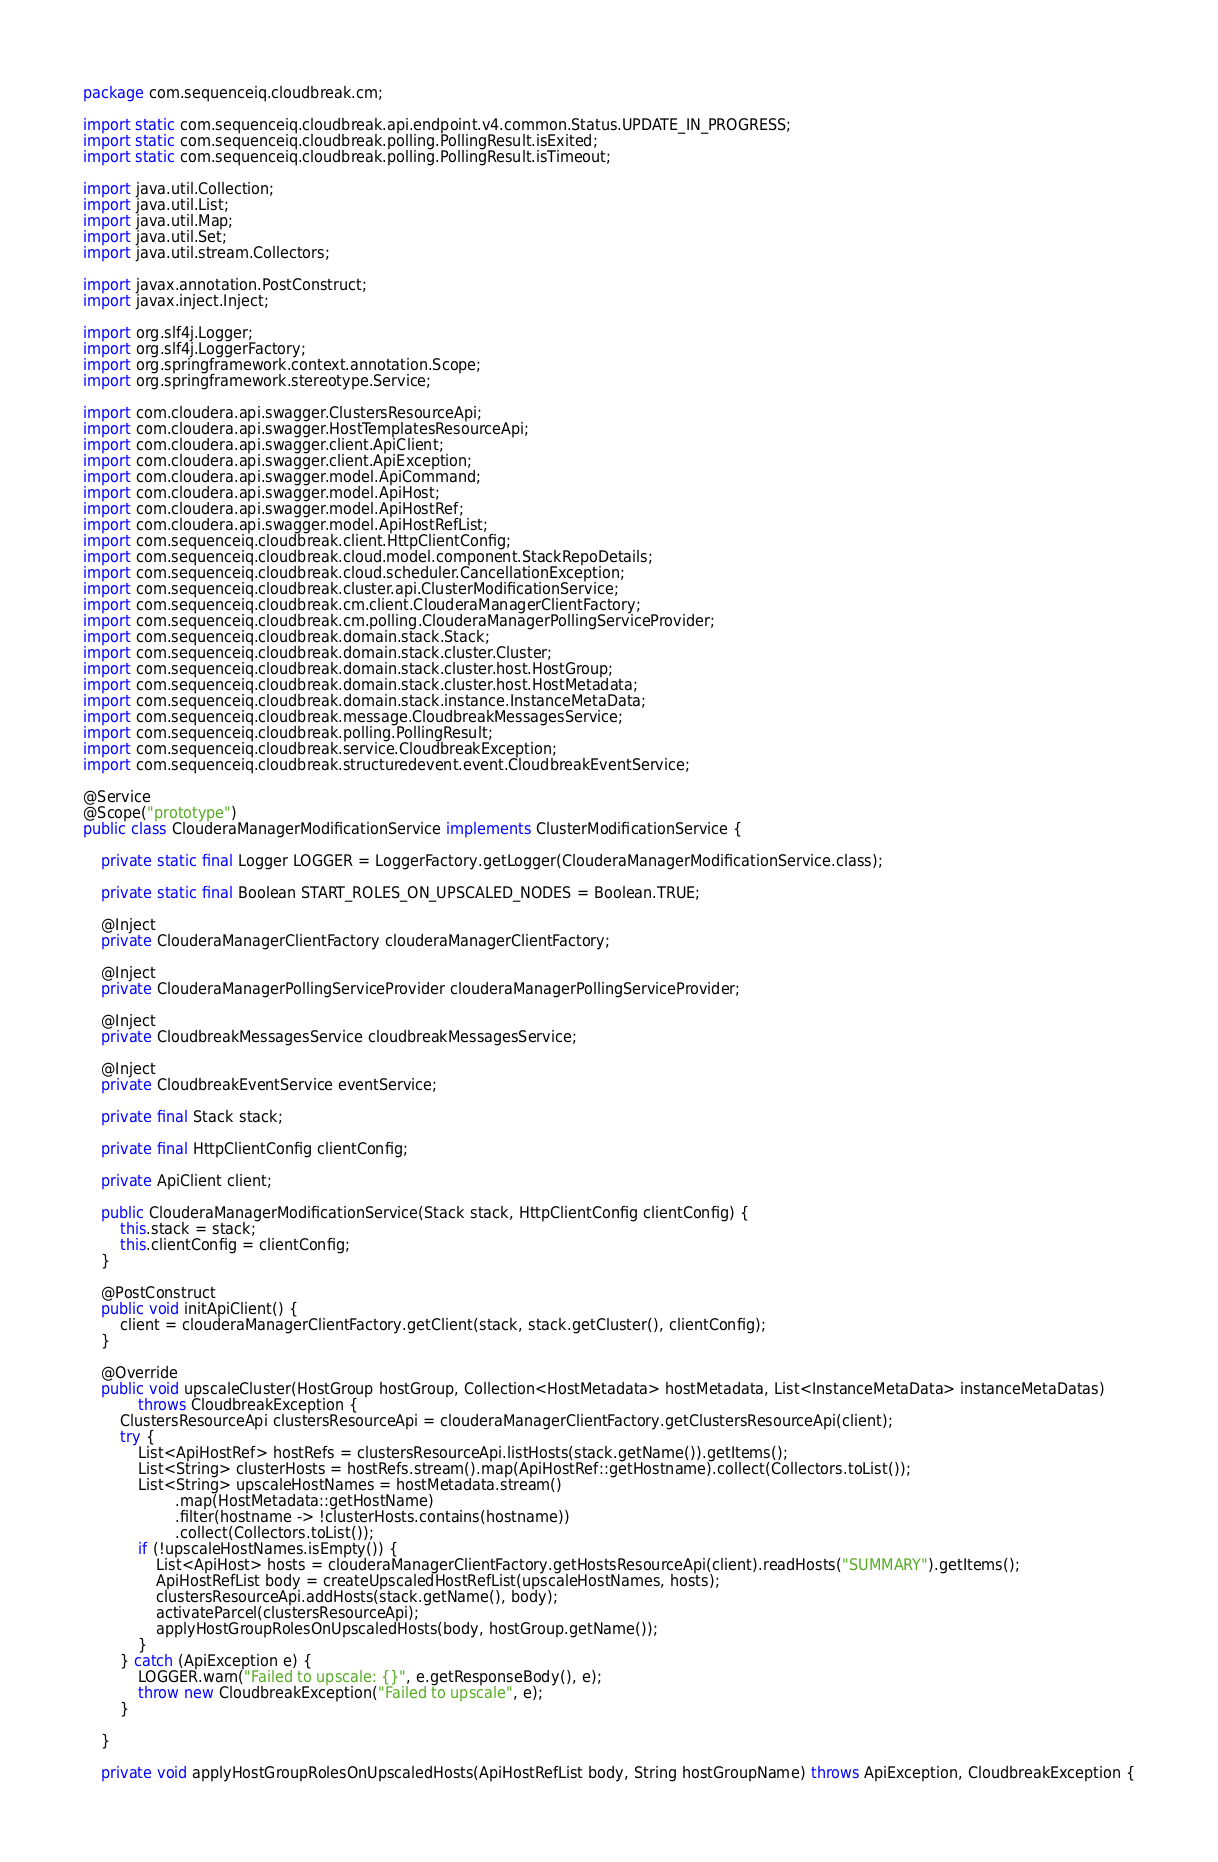Convert code to text. <code><loc_0><loc_0><loc_500><loc_500><_Java_>package com.sequenceiq.cloudbreak.cm;

import static com.sequenceiq.cloudbreak.api.endpoint.v4.common.Status.UPDATE_IN_PROGRESS;
import static com.sequenceiq.cloudbreak.polling.PollingResult.isExited;
import static com.sequenceiq.cloudbreak.polling.PollingResult.isTimeout;

import java.util.Collection;
import java.util.List;
import java.util.Map;
import java.util.Set;
import java.util.stream.Collectors;

import javax.annotation.PostConstruct;
import javax.inject.Inject;

import org.slf4j.Logger;
import org.slf4j.LoggerFactory;
import org.springframework.context.annotation.Scope;
import org.springframework.stereotype.Service;

import com.cloudera.api.swagger.ClustersResourceApi;
import com.cloudera.api.swagger.HostTemplatesResourceApi;
import com.cloudera.api.swagger.client.ApiClient;
import com.cloudera.api.swagger.client.ApiException;
import com.cloudera.api.swagger.model.ApiCommand;
import com.cloudera.api.swagger.model.ApiHost;
import com.cloudera.api.swagger.model.ApiHostRef;
import com.cloudera.api.swagger.model.ApiHostRefList;
import com.sequenceiq.cloudbreak.client.HttpClientConfig;
import com.sequenceiq.cloudbreak.cloud.model.component.StackRepoDetails;
import com.sequenceiq.cloudbreak.cloud.scheduler.CancellationException;
import com.sequenceiq.cloudbreak.cluster.api.ClusterModificationService;
import com.sequenceiq.cloudbreak.cm.client.ClouderaManagerClientFactory;
import com.sequenceiq.cloudbreak.cm.polling.ClouderaManagerPollingServiceProvider;
import com.sequenceiq.cloudbreak.domain.stack.Stack;
import com.sequenceiq.cloudbreak.domain.stack.cluster.Cluster;
import com.sequenceiq.cloudbreak.domain.stack.cluster.host.HostGroup;
import com.sequenceiq.cloudbreak.domain.stack.cluster.host.HostMetadata;
import com.sequenceiq.cloudbreak.domain.stack.instance.InstanceMetaData;
import com.sequenceiq.cloudbreak.message.CloudbreakMessagesService;
import com.sequenceiq.cloudbreak.polling.PollingResult;
import com.sequenceiq.cloudbreak.service.CloudbreakException;
import com.sequenceiq.cloudbreak.structuredevent.event.CloudbreakEventService;

@Service
@Scope("prototype")
public class ClouderaManagerModificationService implements ClusterModificationService {

    private static final Logger LOGGER = LoggerFactory.getLogger(ClouderaManagerModificationService.class);

    private static final Boolean START_ROLES_ON_UPSCALED_NODES = Boolean.TRUE;

    @Inject
    private ClouderaManagerClientFactory clouderaManagerClientFactory;

    @Inject
    private ClouderaManagerPollingServiceProvider clouderaManagerPollingServiceProvider;

    @Inject
    private CloudbreakMessagesService cloudbreakMessagesService;

    @Inject
    private CloudbreakEventService eventService;

    private final Stack stack;

    private final HttpClientConfig clientConfig;

    private ApiClient client;

    public ClouderaManagerModificationService(Stack stack, HttpClientConfig clientConfig) {
        this.stack = stack;
        this.clientConfig = clientConfig;
    }

    @PostConstruct
    public void initApiClient() {
        client = clouderaManagerClientFactory.getClient(stack, stack.getCluster(), clientConfig);
    }

    @Override
    public void upscaleCluster(HostGroup hostGroup, Collection<HostMetadata> hostMetadata, List<InstanceMetaData> instanceMetaDatas)
            throws CloudbreakException {
        ClustersResourceApi clustersResourceApi = clouderaManagerClientFactory.getClustersResourceApi(client);
        try {
            List<ApiHostRef> hostRefs = clustersResourceApi.listHosts(stack.getName()).getItems();
            List<String> clusterHosts = hostRefs.stream().map(ApiHostRef::getHostname).collect(Collectors.toList());
            List<String> upscaleHostNames = hostMetadata.stream()
                    .map(HostMetadata::getHostName)
                    .filter(hostname -> !clusterHosts.contains(hostname))
                    .collect(Collectors.toList());
            if (!upscaleHostNames.isEmpty()) {
                List<ApiHost> hosts = clouderaManagerClientFactory.getHostsResourceApi(client).readHosts("SUMMARY").getItems();
                ApiHostRefList body = createUpscaledHostRefList(upscaleHostNames, hosts);
                clustersResourceApi.addHosts(stack.getName(), body);
                activateParcel(clustersResourceApi);
                applyHostGroupRolesOnUpscaledHosts(body, hostGroup.getName());
            }
        } catch (ApiException e) {
            LOGGER.warn("Failed to upscale: {}", e.getResponseBody(), e);
            throw new CloudbreakException("Failed to upscale", e);
        }

    }

    private void applyHostGroupRolesOnUpscaledHosts(ApiHostRefList body, String hostGroupName) throws ApiException, CloudbreakException {</code> 